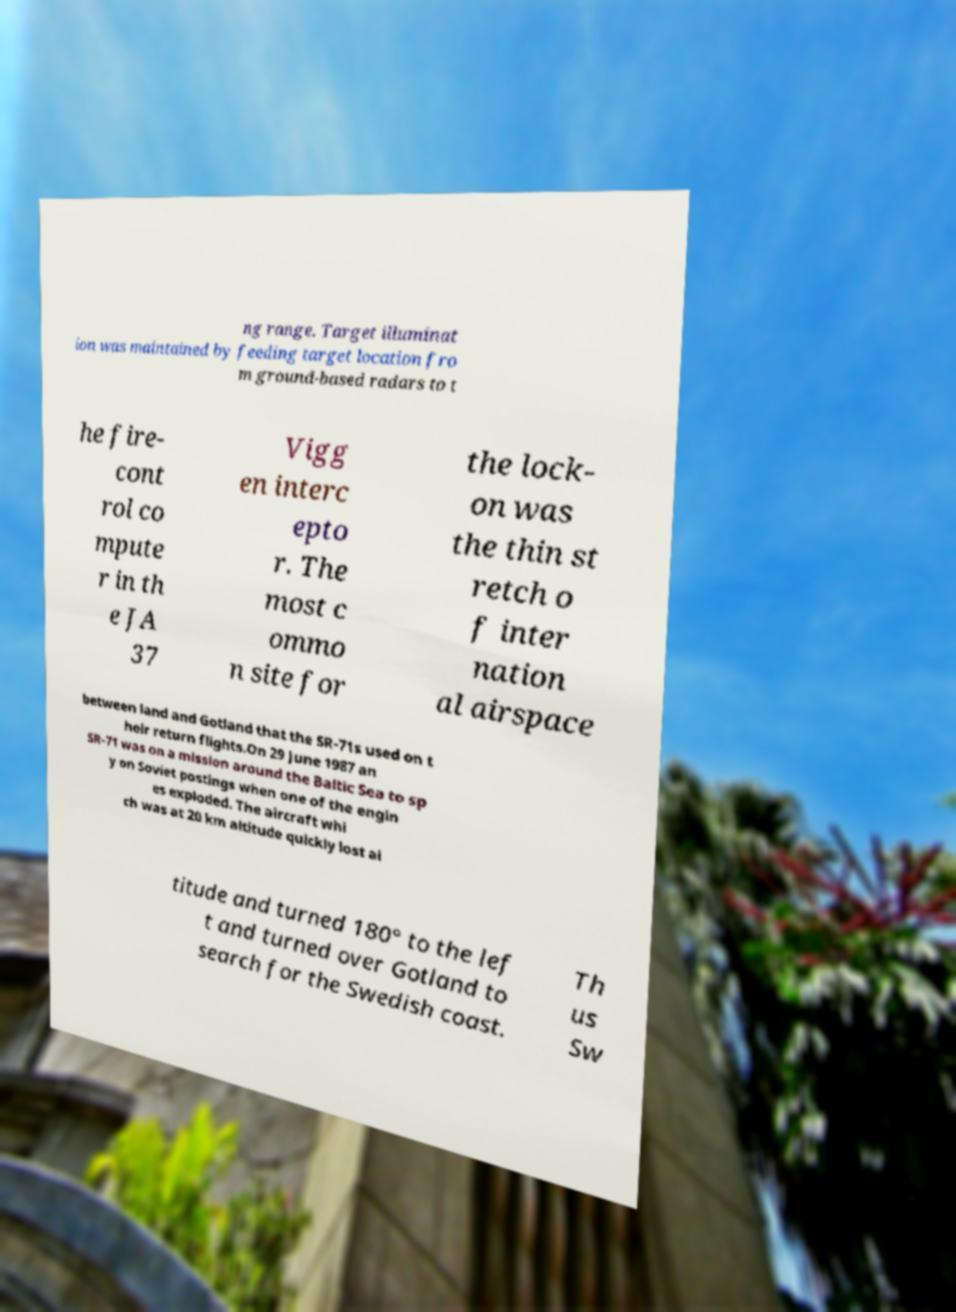Could you extract and type out the text from this image? ng range. Target illuminat ion was maintained by feeding target location fro m ground-based radars to t he fire- cont rol co mpute r in th e JA 37 Vigg en interc epto r. The most c ommo n site for the lock- on was the thin st retch o f inter nation al airspace between land and Gotland that the SR-71s used on t heir return flights.On 29 June 1987 an SR-71 was on a mission around the Baltic Sea to sp y on Soviet postings when one of the engin es exploded. The aircraft whi ch was at 20 km altitude quickly lost al titude and turned 180° to the lef t and turned over Gotland to search for the Swedish coast. Th us Sw 